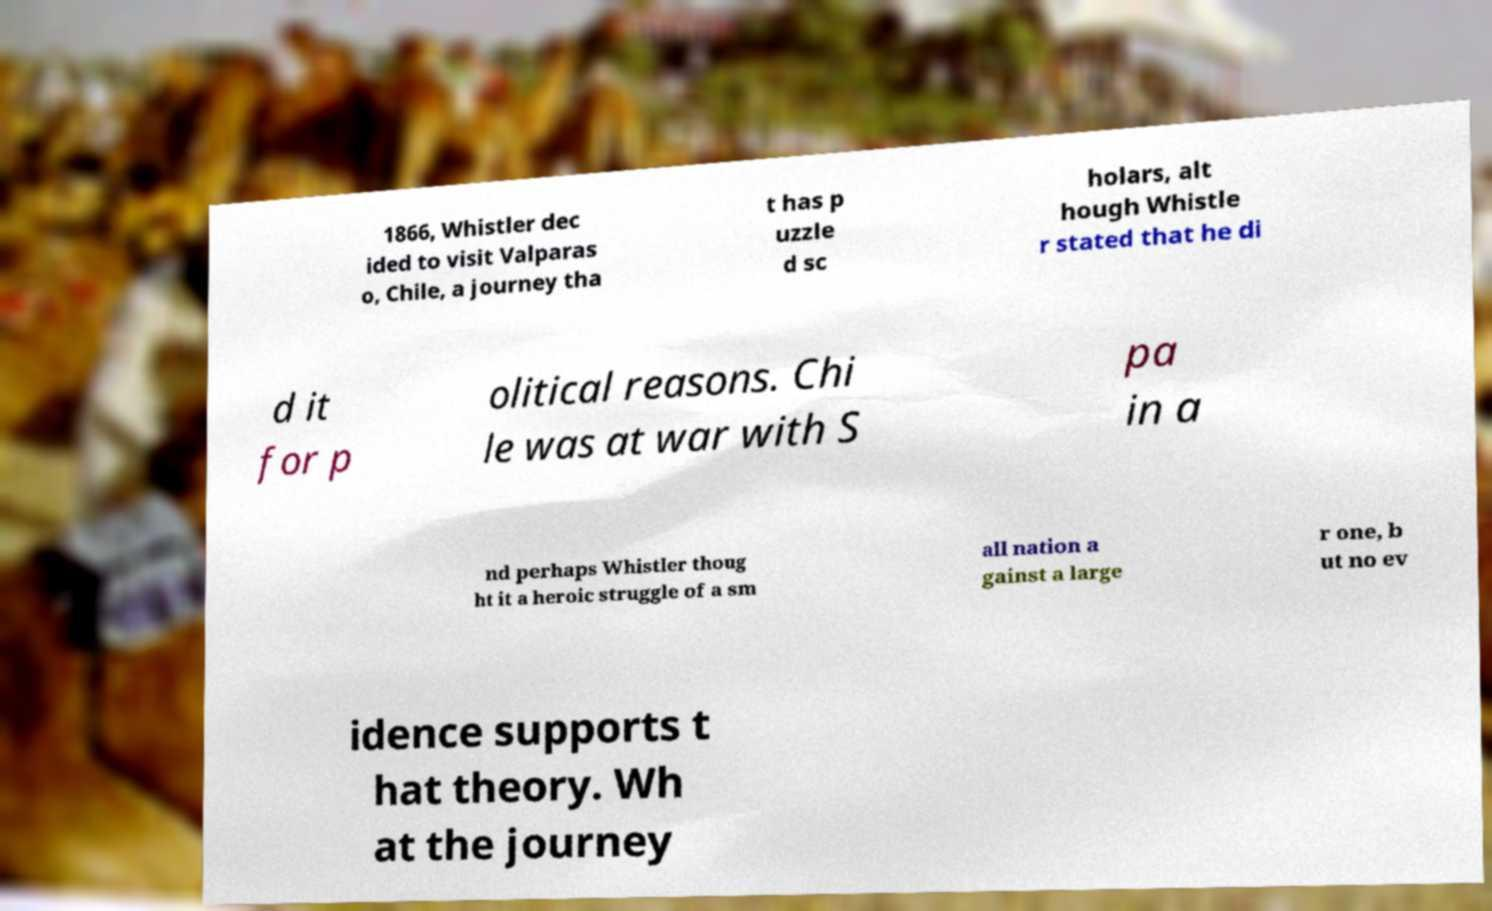Can you accurately transcribe the text from the provided image for me? 1866, Whistler dec ided to visit Valparas o, Chile, a journey tha t has p uzzle d sc holars, alt hough Whistle r stated that he di d it for p olitical reasons. Chi le was at war with S pa in a nd perhaps Whistler thoug ht it a heroic struggle of a sm all nation a gainst a large r one, b ut no ev idence supports t hat theory. Wh at the journey 